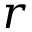<formula> <loc_0><loc_0><loc_500><loc_500>r</formula> 